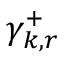Convert formula to latex. <formula><loc_0><loc_0><loc_500><loc_500>\gamma _ { k , r } ^ { + }</formula> 